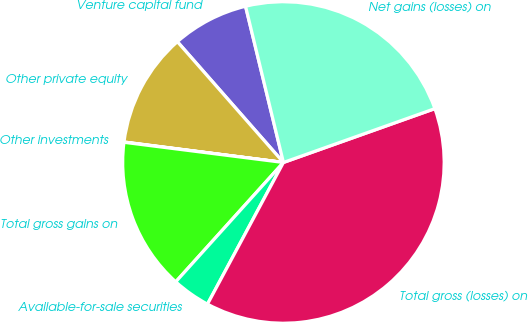<chart> <loc_0><loc_0><loc_500><loc_500><pie_chart><fcel>Venture capital fund<fcel>Other private equity<fcel>Other investments<fcel>Total gross gains on<fcel>Available-for-sale securities<fcel>Total gross (losses) on<fcel>Net gains (losses) on<nl><fcel>7.68%<fcel>11.5%<fcel>0.03%<fcel>15.32%<fcel>3.85%<fcel>38.27%<fcel>23.35%<nl></chart> 